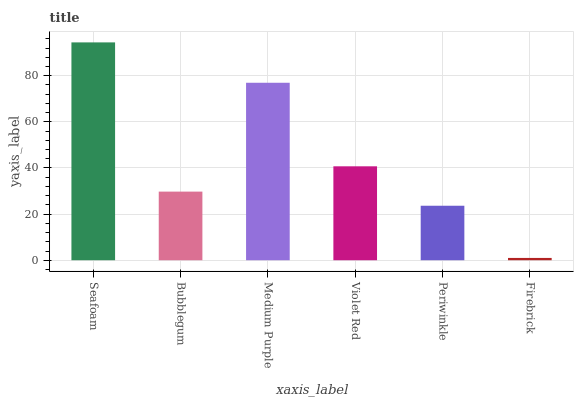Is Firebrick the minimum?
Answer yes or no. Yes. Is Seafoam the maximum?
Answer yes or no. Yes. Is Bubblegum the minimum?
Answer yes or no. No. Is Bubblegum the maximum?
Answer yes or no. No. Is Seafoam greater than Bubblegum?
Answer yes or no. Yes. Is Bubblegum less than Seafoam?
Answer yes or no. Yes. Is Bubblegum greater than Seafoam?
Answer yes or no. No. Is Seafoam less than Bubblegum?
Answer yes or no. No. Is Violet Red the high median?
Answer yes or no. Yes. Is Bubblegum the low median?
Answer yes or no. Yes. Is Firebrick the high median?
Answer yes or no. No. Is Firebrick the low median?
Answer yes or no. No. 